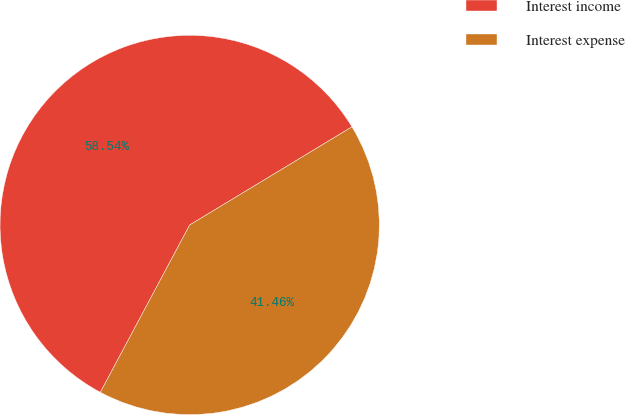Convert chart to OTSL. <chart><loc_0><loc_0><loc_500><loc_500><pie_chart><fcel>Interest income<fcel>Interest expense<nl><fcel>58.54%<fcel>41.46%<nl></chart> 